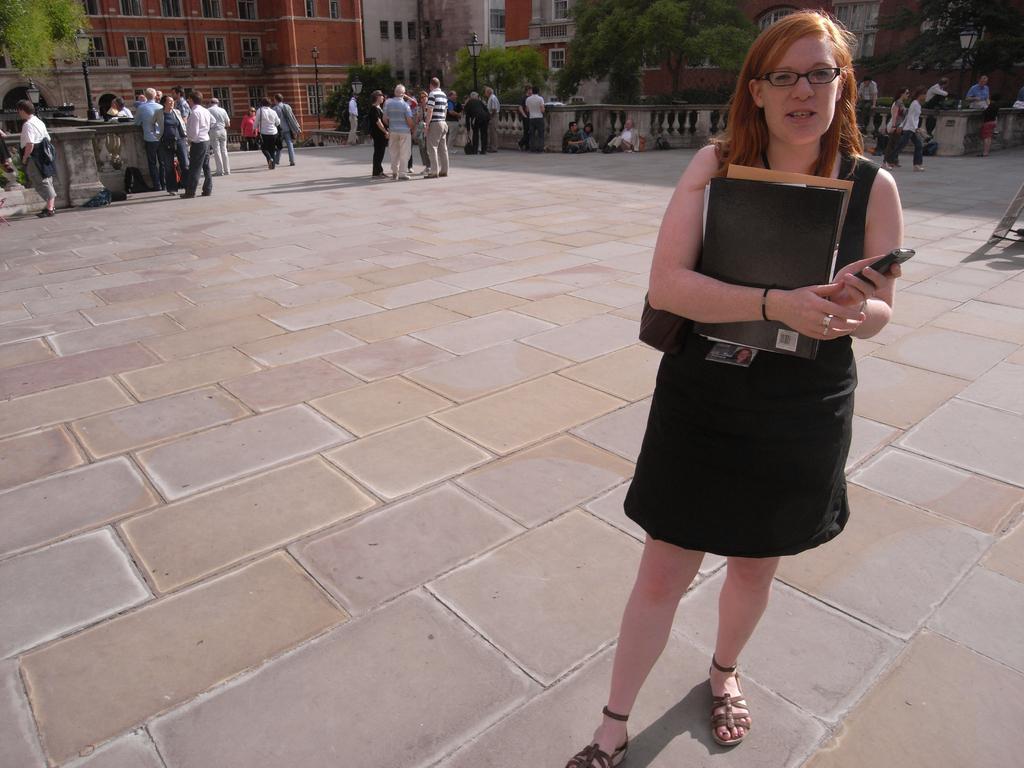Please provide a concise description of this image. In this image there is a road at the bottom. There are people, trees, poles on the left corner. There is a person standing and holding an object in the foreground. There are trees, buildings, people on the right corner. There are buildings, people, poles with lights, trees in the background. 